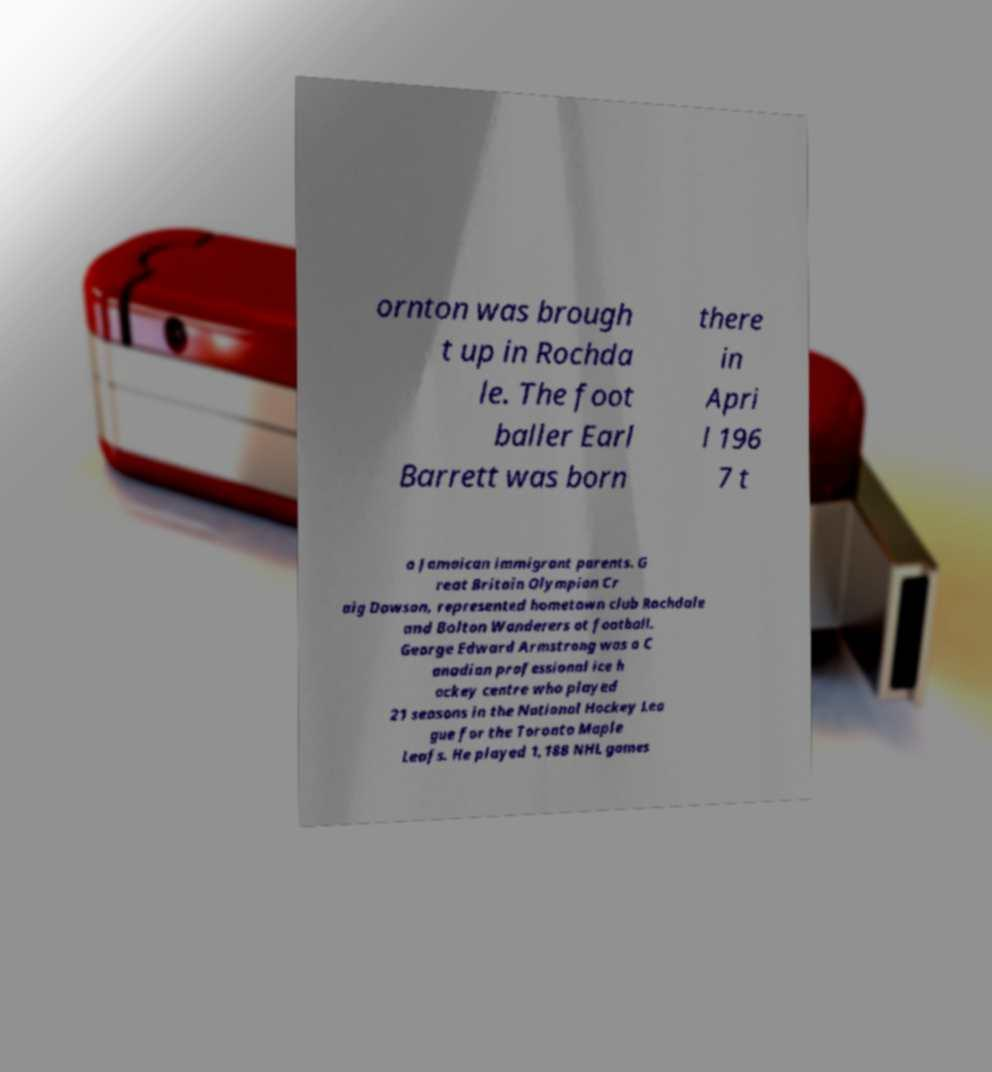There's text embedded in this image that I need extracted. Can you transcribe it verbatim? ornton was brough t up in Rochda le. The foot baller Earl Barrett was born there in Apri l 196 7 t o Jamaican immigrant parents. G reat Britain Olympian Cr aig Dawson, represented hometown club Rochdale and Bolton Wanderers at football. George Edward Armstrong was a C anadian professional ice h ockey centre who played 21 seasons in the National Hockey Lea gue for the Toronto Maple Leafs. He played 1,188 NHL games 